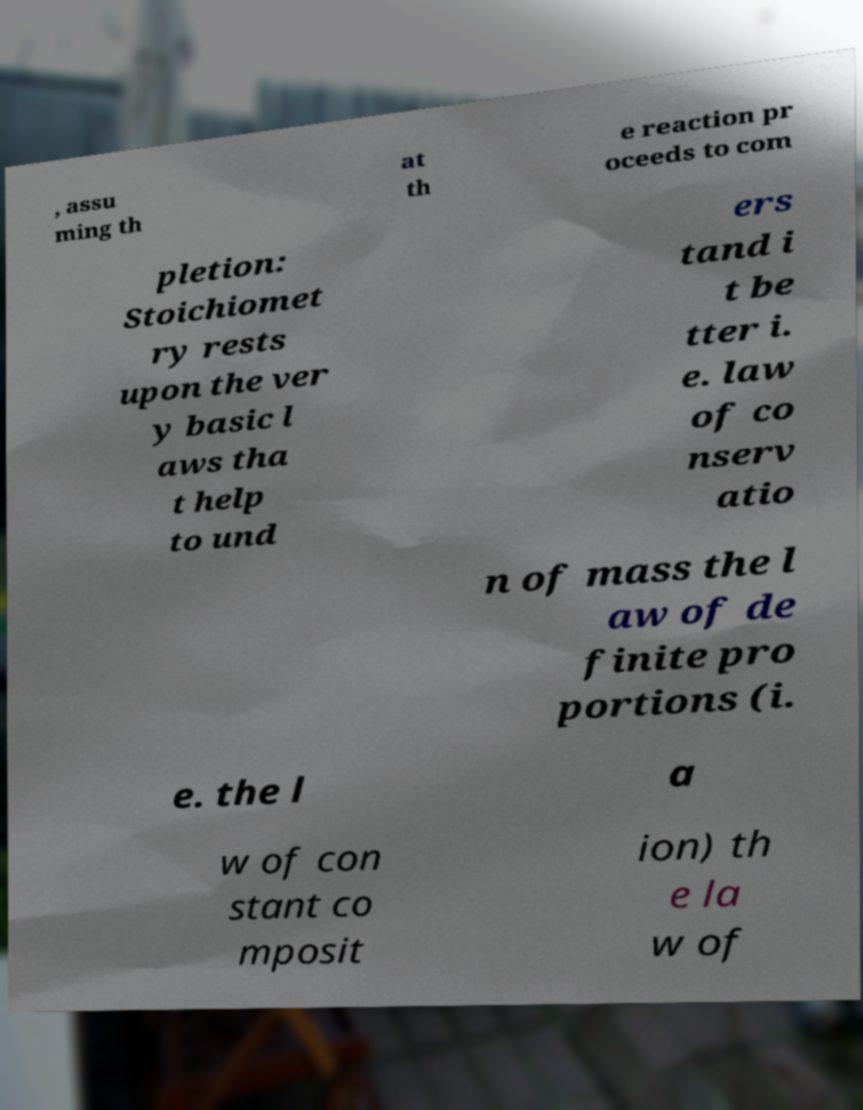I need the written content from this picture converted into text. Can you do that? , assu ming th at th e reaction pr oceeds to com pletion: Stoichiomet ry rests upon the ver y basic l aws tha t help to und ers tand i t be tter i. e. law of co nserv atio n of mass the l aw of de finite pro portions (i. e. the l a w of con stant co mposit ion) th e la w of 